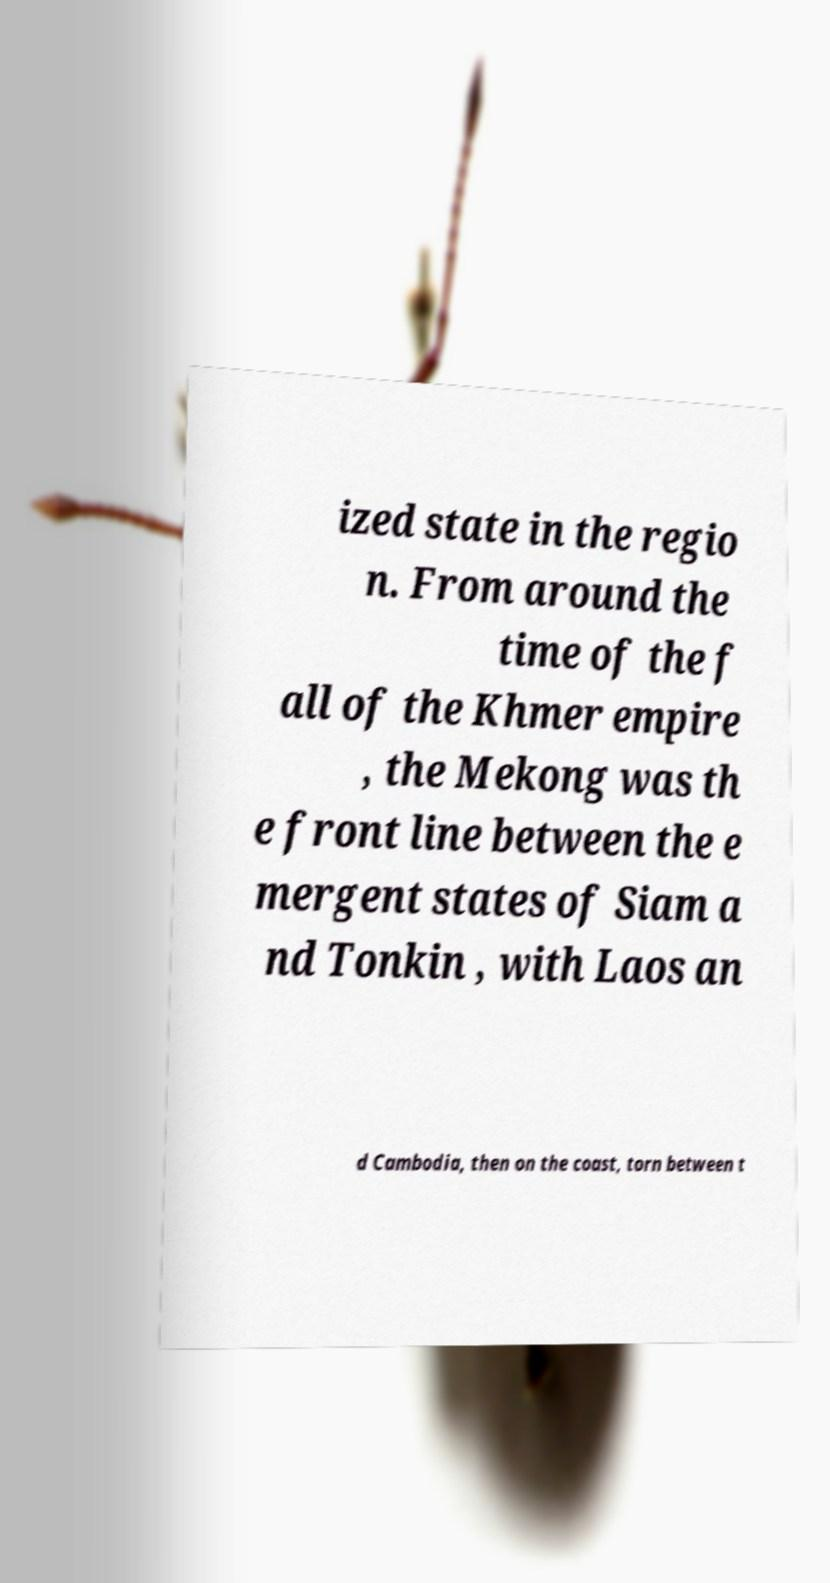I need the written content from this picture converted into text. Can you do that? ized state in the regio n. From around the time of the f all of the Khmer empire , the Mekong was th e front line between the e mergent states of Siam a nd Tonkin , with Laos an d Cambodia, then on the coast, torn between t 